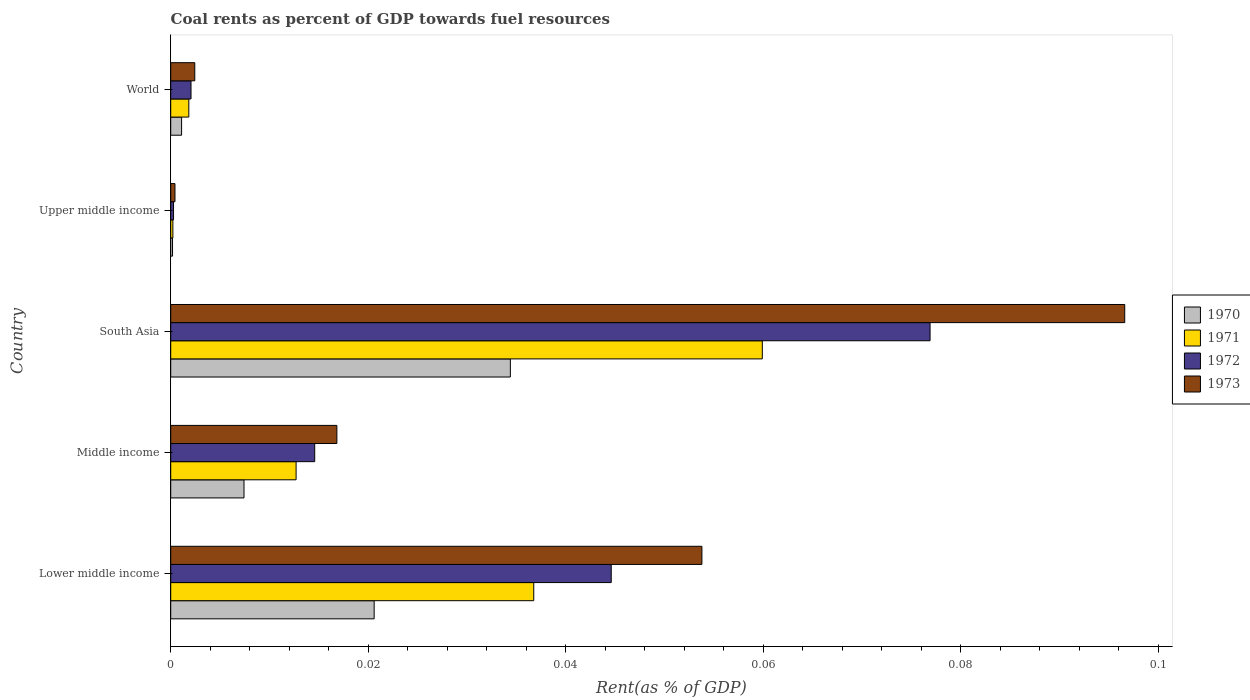How many different coloured bars are there?
Provide a succinct answer. 4. How many groups of bars are there?
Make the answer very short. 5. How many bars are there on the 4th tick from the top?
Provide a succinct answer. 4. What is the label of the 3rd group of bars from the top?
Provide a succinct answer. South Asia. What is the coal rent in 1971 in Lower middle income?
Your response must be concise. 0.04. Across all countries, what is the maximum coal rent in 1972?
Keep it short and to the point. 0.08. Across all countries, what is the minimum coal rent in 1972?
Make the answer very short. 0. In which country was the coal rent in 1970 maximum?
Give a very brief answer. South Asia. In which country was the coal rent in 1971 minimum?
Make the answer very short. Upper middle income. What is the total coal rent in 1970 in the graph?
Offer a very short reply. 0.06. What is the difference between the coal rent in 1972 in Middle income and that in Upper middle income?
Your answer should be very brief. 0.01. What is the difference between the coal rent in 1973 in South Asia and the coal rent in 1970 in Middle income?
Keep it short and to the point. 0.09. What is the average coal rent in 1972 per country?
Ensure brevity in your answer.  0.03. What is the difference between the coal rent in 1973 and coal rent in 1970 in Lower middle income?
Your answer should be very brief. 0.03. What is the ratio of the coal rent in 1970 in Lower middle income to that in Upper middle income?
Ensure brevity in your answer.  112.03. Is the coal rent in 1972 in South Asia less than that in World?
Keep it short and to the point. No. Is the difference between the coal rent in 1973 in Middle income and South Asia greater than the difference between the coal rent in 1970 in Middle income and South Asia?
Your answer should be compact. No. What is the difference between the highest and the second highest coal rent in 1971?
Provide a short and direct response. 0.02. What is the difference between the highest and the lowest coal rent in 1970?
Ensure brevity in your answer.  0.03. How many bars are there?
Give a very brief answer. 20. How many countries are there in the graph?
Your answer should be compact. 5. Does the graph contain grids?
Your answer should be compact. No. How many legend labels are there?
Your answer should be compact. 4. What is the title of the graph?
Give a very brief answer. Coal rents as percent of GDP towards fuel resources. Does "1972" appear as one of the legend labels in the graph?
Ensure brevity in your answer.  Yes. What is the label or title of the X-axis?
Give a very brief answer. Rent(as % of GDP). What is the label or title of the Y-axis?
Make the answer very short. Country. What is the Rent(as % of GDP) in 1970 in Lower middle income?
Your response must be concise. 0.02. What is the Rent(as % of GDP) in 1971 in Lower middle income?
Ensure brevity in your answer.  0.04. What is the Rent(as % of GDP) in 1972 in Lower middle income?
Give a very brief answer. 0.04. What is the Rent(as % of GDP) of 1973 in Lower middle income?
Your response must be concise. 0.05. What is the Rent(as % of GDP) of 1970 in Middle income?
Keep it short and to the point. 0.01. What is the Rent(as % of GDP) of 1971 in Middle income?
Offer a very short reply. 0.01. What is the Rent(as % of GDP) of 1972 in Middle income?
Ensure brevity in your answer.  0.01. What is the Rent(as % of GDP) in 1973 in Middle income?
Offer a terse response. 0.02. What is the Rent(as % of GDP) of 1970 in South Asia?
Provide a succinct answer. 0.03. What is the Rent(as % of GDP) in 1971 in South Asia?
Provide a succinct answer. 0.06. What is the Rent(as % of GDP) of 1972 in South Asia?
Provide a succinct answer. 0.08. What is the Rent(as % of GDP) in 1973 in South Asia?
Your answer should be compact. 0.1. What is the Rent(as % of GDP) of 1970 in Upper middle income?
Keep it short and to the point. 0. What is the Rent(as % of GDP) of 1971 in Upper middle income?
Your answer should be compact. 0. What is the Rent(as % of GDP) in 1972 in Upper middle income?
Offer a terse response. 0. What is the Rent(as % of GDP) of 1973 in Upper middle income?
Your answer should be very brief. 0. What is the Rent(as % of GDP) in 1970 in World?
Your answer should be very brief. 0. What is the Rent(as % of GDP) in 1971 in World?
Offer a very short reply. 0. What is the Rent(as % of GDP) in 1972 in World?
Offer a very short reply. 0. What is the Rent(as % of GDP) of 1973 in World?
Provide a succinct answer. 0. Across all countries, what is the maximum Rent(as % of GDP) of 1970?
Give a very brief answer. 0.03. Across all countries, what is the maximum Rent(as % of GDP) in 1971?
Your response must be concise. 0.06. Across all countries, what is the maximum Rent(as % of GDP) of 1972?
Your response must be concise. 0.08. Across all countries, what is the maximum Rent(as % of GDP) in 1973?
Your response must be concise. 0.1. Across all countries, what is the minimum Rent(as % of GDP) in 1970?
Give a very brief answer. 0. Across all countries, what is the minimum Rent(as % of GDP) in 1971?
Provide a succinct answer. 0. Across all countries, what is the minimum Rent(as % of GDP) in 1972?
Provide a succinct answer. 0. Across all countries, what is the minimum Rent(as % of GDP) in 1973?
Offer a very short reply. 0. What is the total Rent(as % of GDP) in 1970 in the graph?
Your response must be concise. 0.06. What is the total Rent(as % of GDP) in 1971 in the graph?
Your response must be concise. 0.11. What is the total Rent(as % of GDP) in 1972 in the graph?
Make the answer very short. 0.14. What is the total Rent(as % of GDP) of 1973 in the graph?
Your response must be concise. 0.17. What is the difference between the Rent(as % of GDP) in 1970 in Lower middle income and that in Middle income?
Make the answer very short. 0.01. What is the difference between the Rent(as % of GDP) in 1971 in Lower middle income and that in Middle income?
Give a very brief answer. 0.02. What is the difference between the Rent(as % of GDP) in 1972 in Lower middle income and that in Middle income?
Your answer should be compact. 0.03. What is the difference between the Rent(as % of GDP) in 1973 in Lower middle income and that in Middle income?
Your response must be concise. 0.04. What is the difference between the Rent(as % of GDP) in 1970 in Lower middle income and that in South Asia?
Provide a short and direct response. -0.01. What is the difference between the Rent(as % of GDP) of 1971 in Lower middle income and that in South Asia?
Offer a terse response. -0.02. What is the difference between the Rent(as % of GDP) in 1972 in Lower middle income and that in South Asia?
Offer a very short reply. -0.03. What is the difference between the Rent(as % of GDP) of 1973 in Lower middle income and that in South Asia?
Provide a short and direct response. -0.04. What is the difference between the Rent(as % of GDP) in 1970 in Lower middle income and that in Upper middle income?
Offer a very short reply. 0.02. What is the difference between the Rent(as % of GDP) in 1971 in Lower middle income and that in Upper middle income?
Your response must be concise. 0.04. What is the difference between the Rent(as % of GDP) in 1972 in Lower middle income and that in Upper middle income?
Your answer should be very brief. 0.04. What is the difference between the Rent(as % of GDP) in 1973 in Lower middle income and that in Upper middle income?
Provide a succinct answer. 0.05. What is the difference between the Rent(as % of GDP) of 1970 in Lower middle income and that in World?
Make the answer very short. 0.02. What is the difference between the Rent(as % of GDP) in 1971 in Lower middle income and that in World?
Your answer should be very brief. 0.03. What is the difference between the Rent(as % of GDP) in 1972 in Lower middle income and that in World?
Offer a very short reply. 0.04. What is the difference between the Rent(as % of GDP) in 1973 in Lower middle income and that in World?
Your response must be concise. 0.05. What is the difference between the Rent(as % of GDP) of 1970 in Middle income and that in South Asia?
Provide a succinct answer. -0.03. What is the difference between the Rent(as % of GDP) of 1971 in Middle income and that in South Asia?
Provide a succinct answer. -0.05. What is the difference between the Rent(as % of GDP) of 1972 in Middle income and that in South Asia?
Ensure brevity in your answer.  -0.06. What is the difference between the Rent(as % of GDP) in 1973 in Middle income and that in South Asia?
Provide a succinct answer. -0.08. What is the difference between the Rent(as % of GDP) in 1970 in Middle income and that in Upper middle income?
Ensure brevity in your answer.  0.01. What is the difference between the Rent(as % of GDP) of 1971 in Middle income and that in Upper middle income?
Give a very brief answer. 0.01. What is the difference between the Rent(as % of GDP) in 1972 in Middle income and that in Upper middle income?
Offer a terse response. 0.01. What is the difference between the Rent(as % of GDP) of 1973 in Middle income and that in Upper middle income?
Give a very brief answer. 0.02. What is the difference between the Rent(as % of GDP) in 1970 in Middle income and that in World?
Offer a terse response. 0.01. What is the difference between the Rent(as % of GDP) of 1971 in Middle income and that in World?
Offer a terse response. 0.01. What is the difference between the Rent(as % of GDP) of 1972 in Middle income and that in World?
Ensure brevity in your answer.  0.01. What is the difference between the Rent(as % of GDP) in 1973 in Middle income and that in World?
Your answer should be very brief. 0.01. What is the difference between the Rent(as % of GDP) of 1970 in South Asia and that in Upper middle income?
Provide a succinct answer. 0.03. What is the difference between the Rent(as % of GDP) of 1971 in South Asia and that in Upper middle income?
Give a very brief answer. 0.06. What is the difference between the Rent(as % of GDP) of 1972 in South Asia and that in Upper middle income?
Your response must be concise. 0.08. What is the difference between the Rent(as % of GDP) in 1973 in South Asia and that in Upper middle income?
Ensure brevity in your answer.  0.1. What is the difference between the Rent(as % of GDP) of 1970 in South Asia and that in World?
Your answer should be compact. 0.03. What is the difference between the Rent(as % of GDP) in 1971 in South Asia and that in World?
Your response must be concise. 0.06. What is the difference between the Rent(as % of GDP) in 1972 in South Asia and that in World?
Ensure brevity in your answer.  0.07. What is the difference between the Rent(as % of GDP) in 1973 in South Asia and that in World?
Your response must be concise. 0.09. What is the difference between the Rent(as % of GDP) of 1970 in Upper middle income and that in World?
Offer a terse response. -0. What is the difference between the Rent(as % of GDP) of 1971 in Upper middle income and that in World?
Your answer should be compact. -0. What is the difference between the Rent(as % of GDP) of 1972 in Upper middle income and that in World?
Offer a terse response. -0. What is the difference between the Rent(as % of GDP) of 1973 in Upper middle income and that in World?
Your answer should be compact. -0. What is the difference between the Rent(as % of GDP) in 1970 in Lower middle income and the Rent(as % of GDP) in 1971 in Middle income?
Provide a short and direct response. 0.01. What is the difference between the Rent(as % of GDP) in 1970 in Lower middle income and the Rent(as % of GDP) in 1972 in Middle income?
Offer a terse response. 0.01. What is the difference between the Rent(as % of GDP) of 1970 in Lower middle income and the Rent(as % of GDP) of 1973 in Middle income?
Your answer should be compact. 0. What is the difference between the Rent(as % of GDP) in 1971 in Lower middle income and the Rent(as % of GDP) in 1972 in Middle income?
Your response must be concise. 0.02. What is the difference between the Rent(as % of GDP) in 1971 in Lower middle income and the Rent(as % of GDP) in 1973 in Middle income?
Provide a short and direct response. 0.02. What is the difference between the Rent(as % of GDP) of 1972 in Lower middle income and the Rent(as % of GDP) of 1973 in Middle income?
Your response must be concise. 0.03. What is the difference between the Rent(as % of GDP) in 1970 in Lower middle income and the Rent(as % of GDP) in 1971 in South Asia?
Provide a succinct answer. -0.04. What is the difference between the Rent(as % of GDP) of 1970 in Lower middle income and the Rent(as % of GDP) of 1972 in South Asia?
Give a very brief answer. -0.06. What is the difference between the Rent(as % of GDP) of 1970 in Lower middle income and the Rent(as % of GDP) of 1973 in South Asia?
Provide a succinct answer. -0.08. What is the difference between the Rent(as % of GDP) in 1971 in Lower middle income and the Rent(as % of GDP) in 1972 in South Asia?
Provide a short and direct response. -0.04. What is the difference between the Rent(as % of GDP) of 1971 in Lower middle income and the Rent(as % of GDP) of 1973 in South Asia?
Provide a short and direct response. -0.06. What is the difference between the Rent(as % of GDP) in 1972 in Lower middle income and the Rent(as % of GDP) in 1973 in South Asia?
Your answer should be compact. -0.05. What is the difference between the Rent(as % of GDP) of 1970 in Lower middle income and the Rent(as % of GDP) of 1971 in Upper middle income?
Keep it short and to the point. 0.02. What is the difference between the Rent(as % of GDP) in 1970 in Lower middle income and the Rent(as % of GDP) in 1972 in Upper middle income?
Make the answer very short. 0.02. What is the difference between the Rent(as % of GDP) in 1970 in Lower middle income and the Rent(as % of GDP) in 1973 in Upper middle income?
Offer a very short reply. 0.02. What is the difference between the Rent(as % of GDP) in 1971 in Lower middle income and the Rent(as % of GDP) in 1972 in Upper middle income?
Provide a short and direct response. 0.04. What is the difference between the Rent(as % of GDP) in 1971 in Lower middle income and the Rent(as % of GDP) in 1973 in Upper middle income?
Provide a succinct answer. 0.04. What is the difference between the Rent(as % of GDP) of 1972 in Lower middle income and the Rent(as % of GDP) of 1973 in Upper middle income?
Ensure brevity in your answer.  0.04. What is the difference between the Rent(as % of GDP) in 1970 in Lower middle income and the Rent(as % of GDP) in 1971 in World?
Provide a succinct answer. 0.02. What is the difference between the Rent(as % of GDP) in 1970 in Lower middle income and the Rent(as % of GDP) in 1972 in World?
Your response must be concise. 0.02. What is the difference between the Rent(as % of GDP) of 1970 in Lower middle income and the Rent(as % of GDP) of 1973 in World?
Your response must be concise. 0.02. What is the difference between the Rent(as % of GDP) of 1971 in Lower middle income and the Rent(as % of GDP) of 1972 in World?
Provide a succinct answer. 0.03. What is the difference between the Rent(as % of GDP) in 1971 in Lower middle income and the Rent(as % of GDP) in 1973 in World?
Offer a terse response. 0.03. What is the difference between the Rent(as % of GDP) in 1972 in Lower middle income and the Rent(as % of GDP) in 1973 in World?
Make the answer very short. 0.04. What is the difference between the Rent(as % of GDP) in 1970 in Middle income and the Rent(as % of GDP) in 1971 in South Asia?
Provide a short and direct response. -0.05. What is the difference between the Rent(as % of GDP) of 1970 in Middle income and the Rent(as % of GDP) of 1972 in South Asia?
Provide a short and direct response. -0.07. What is the difference between the Rent(as % of GDP) of 1970 in Middle income and the Rent(as % of GDP) of 1973 in South Asia?
Give a very brief answer. -0.09. What is the difference between the Rent(as % of GDP) of 1971 in Middle income and the Rent(as % of GDP) of 1972 in South Asia?
Your answer should be very brief. -0.06. What is the difference between the Rent(as % of GDP) in 1971 in Middle income and the Rent(as % of GDP) in 1973 in South Asia?
Offer a terse response. -0.08. What is the difference between the Rent(as % of GDP) in 1972 in Middle income and the Rent(as % of GDP) in 1973 in South Asia?
Provide a succinct answer. -0.08. What is the difference between the Rent(as % of GDP) in 1970 in Middle income and the Rent(as % of GDP) in 1971 in Upper middle income?
Provide a short and direct response. 0.01. What is the difference between the Rent(as % of GDP) of 1970 in Middle income and the Rent(as % of GDP) of 1972 in Upper middle income?
Your answer should be compact. 0.01. What is the difference between the Rent(as % of GDP) of 1970 in Middle income and the Rent(as % of GDP) of 1973 in Upper middle income?
Your answer should be very brief. 0.01. What is the difference between the Rent(as % of GDP) in 1971 in Middle income and the Rent(as % of GDP) in 1972 in Upper middle income?
Ensure brevity in your answer.  0.01. What is the difference between the Rent(as % of GDP) of 1971 in Middle income and the Rent(as % of GDP) of 1973 in Upper middle income?
Provide a short and direct response. 0.01. What is the difference between the Rent(as % of GDP) of 1972 in Middle income and the Rent(as % of GDP) of 1973 in Upper middle income?
Offer a very short reply. 0.01. What is the difference between the Rent(as % of GDP) in 1970 in Middle income and the Rent(as % of GDP) in 1971 in World?
Offer a terse response. 0.01. What is the difference between the Rent(as % of GDP) of 1970 in Middle income and the Rent(as % of GDP) of 1972 in World?
Give a very brief answer. 0.01. What is the difference between the Rent(as % of GDP) in 1970 in Middle income and the Rent(as % of GDP) in 1973 in World?
Your response must be concise. 0.01. What is the difference between the Rent(as % of GDP) in 1971 in Middle income and the Rent(as % of GDP) in 1972 in World?
Offer a very short reply. 0.01. What is the difference between the Rent(as % of GDP) in 1971 in Middle income and the Rent(as % of GDP) in 1973 in World?
Provide a succinct answer. 0.01. What is the difference between the Rent(as % of GDP) of 1972 in Middle income and the Rent(as % of GDP) of 1973 in World?
Ensure brevity in your answer.  0.01. What is the difference between the Rent(as % of GDP) of 1970 in South Asia and the Rent(as % of GDP) of 1971 in Upper middle income?
Your answer should be compact. 0.03. What is the difference between the Rent(as % of GDP) of 1970 in South Asia and the Rent(as % of GDP) of 1972 in Upper middle income?
Your answer should be compact. 0.03. What is the difference between the Rent(as % of GDP) in 1970 in South Asia and the Rent(as % of GDP) in 1973 in Upper middle income?
Offer a very short reply. 0.03. What is the difference between the Rent(as % of GDP) of 1971 in South Asia and the Rent(as % of GDP) of 1972 in Upper middle income?
Offer a very short reply. 0.06. What is the difference between the Rent(as % of GDP) in 1971 in South Asia and the Rent(as % of GDP) in 1973 in Upper middle income?
Give a very brief answer. 0.06. What is the difference between the Rent(as % of GDP) of 1972 in South Asia and the Rent(as % of GDP) of 1973 in Upper middle income?
Your answer should be very brief. 0.08. What is the difference between the Rent(as % of GDP) in 1970 in South Asia and the Rent(as % of GDP) in 1971 in World?
Your answer should be very brief. 0.03. What is the difference between the Rent(as % of GDP) of 1970 in South Asia and the Rent(as % of GDP) of 1972 in World?
Offer a very short reply. 0.03. What is the difference between the Rent(as % of GDP) of 1970 in South Asia and the Rent(as % of GDP) of 1973 in World?
Make the answer very short. 0.03. What is the difference between the Rent(as % of GDP) of 1971 in South Asia and the Rent(as % of GDP) of 1972 in World?
Offer a terse response. 0.06. What is the difference between the Rent(as % of GDP) of 1971 in South Asia and the Rent(as % of GDP) of 1973 in World?
Offer a very short reply. 0.06. What is the difference between the Rent(as % of GDP) in 1972 in South Asia and the Rent(as % of GDP) in 1973 in World?
Your response must be concise. 0.07. What is the difference between the Rent(as % of GDP) in 1970 in Upper middle income and the Rent(as % of GDP) in 1971 in World?
Offer a terse response. -0. What is the difference between the Rent(as % of GDP) of 1970 in Upper middle income and the Rent(as % of GDP) of 1972 in World?
Make the answer very short. -0. What is the difference between the Rent(as % of GDP) in 1970 in Upper middle income and the Rent(as % of GDP) in 1973 in World?
Make the answer very short. -0. What is the difference between the Rent(as % of GDP) in 1971 in Upper middle income and the Rent(as % of GDP) in 1972 in World?
Your response must be concise. -0. What is the difference between the Rent(as % of GDP) of 1971 in Upper middle income and the Rent(as % of GDP) of 1973 in World?
Your response must be concise. -0. What is the difference between the Rent(as % of GDP) in 1972 in Upper middle income and the Rent(as % of GDP) in 1973 in World?
Your answer should be compact. -0. What is the average Rent(as % of GDP) in 1970 per country?
Provide a succinct answer. 0.01. What is the average Rent(as % of GDP) in 1971 per country?
Make the answer very short. 0.02. What is the average Rent(as % of GDP) in 1972 per country?
Keep it short and to the point. 0.03. What is the average Rent(as % of GDP) of 1973 per country?
Provide a short and direct response. 0.03. What is the difference between the Rent(as % of GDP) of 1970 and Rent(as % of GDP) of 1971 in Lower middle income?
Your answer should be compact. -0.02. What is the difference between the Rent(as % of GDP) in 1970 and Rent(as % of GDP) in 1972 in Lower middle income?
Keep it short and to the point. -0.02. What is the difference between the Rent(as % of GDP) of 1970 and Rent(as % of GDP) of 1973 in Lower middle income?
Provide a short and direct response. -0.03. What is the difference between the Rent(as % of GDP) of 1971 and Rent(as % of GDP) of 1972 in Lower middle income?
Your answer should be compact. -0.01. What is the difference between the Rent(as % of GDP) of 1971 and Rent(as % of GDP) of 1973 in Lower middle income?
Ensure brevity in your answer.  -0.02. What is the difference between the Rent(as % of GDP) of 1972 and Rent(as % of GDP) of 1973 in Lower middle income?
Your answer should be very brief. -0.01. What is the difference between the Rent(as % of GDP) of 1970 and Rent(as % of GDP) of 1971 in Middle income?
Keep it short and to the point. -0.01. What is the difference between the Rent(as % of GDP) of 1970 and Rent(as % of GDP) of 1972 in Middle income?
Your answer should be very brief. -0.01. What is the difference between the Rent(as % of GDP) of 1970 and Rent(as % of GDP) of 1973 in Middle income?
Make the answer very short. -0.01. What is the difference between the Rent(as % of GDP) in 1971 and Rent(as % of GDP) in 1972 in Middle income?
Give a very brief answer. -0. What is the difference between the Rent(as % of GDP) in 1971 and Rent(as % of GDP) in 1973 in Middle income?
Keep it short and to the point. -0. What is the difference between the Rent(as % of GDP) of 1972 and Rent(as % of GDP) of 1973 in Middle income?
Your answer should be compact. -0. What is the difference between the Rent(as % of GDP) in 1970 and Rent(as % of GDP) in 1971 in South Asia?
Ensure brevity in your answer.  -0.03. What is the difference between the Rent(as % of GDP) of 1970 and Rent(as % of GDP) of 1972 in South Asia?
Make the answer very short. -0.04. What is the difference between the Rent(as % of GDP) in 1970 and Rent(as % of GDP) in 1973 in South Asia?
Make the answer very short. -0.06. What is the difference between the Rent(as % of GDP) in 1971 and Rent(as % of GDP) in 1972 in South Asia?
Ensure brevity in your answer.  -0.02. What is the difference between the Rent(as % of GDP) of 1971 and Rent(as % of GDP) of 1973 in South Asia?
Your answer should be very brief. -0.04. What is the difference between the Rent(as % of GDP) in 1972 and Rent(as % of GDP) in 1973 in South Asia?
Provide a short and direct response. -0.02. What is the difference between the Rent(as % of GDP) of 1970 and Rent(as % of GDP) of 1972 in Upper middle income?
Offer a very short reply. -0. What is the difference between the Rent(as % of GDP) of 1970 and Rent(as % of GDP) of 1973 in Upper middle income?
Ensure brevity in your answer.  -0. What is the difference between the Rent(as % of GDP) of 1971 and Rent(as % of GDP) of 1972 in Upper middle income?
Your answer should be very brief. -0. What is the difference between the Rent(as % of GDP) in 1971 and Rent(as % of GDP) in 1973 in Upper middle income?
Give a very brief answer. -0. What is the difference between the Rent(as % of GDP) in 1972 and Rent(as % of GDP) in 1973 in Upper middle income?
Provide a succinct answer. -0. What is the difference between the Rent(as % of GDP) of 1970 and Rent(as % of GDP) of 1971 in World?
Offer a terse response. -0. What is the difference between the Rent(as % of GDP) in 1970 and Rent(as % of GDP) in 1972 in World?
Give a very brief answer. -0. What is the difference between the Rent(as % of GDP) of 1970 and Rent(as % of GDP) of 1973 in World?
Your answer should be compact. -0. What is the difference between the Rent(as % of GDP) of 1971 and Rent(as % of GDP) of 1972 in World?
Offer a very short reply. -0. What is the difference between the Rent(as % of GDP) of 1971 and Rent(as % of GDP) of 1973 in World?
Make the answer very short. -0. What is the difference between the Rent(as % of GDP) of 1972 and Rent(as % of GDP) of 1973 in World?
Give a very brief answer. -0. What is the ratio of the Rent(as % of GDP) in 1970 in Lower middle income to that in Middle income?
Your response must be concise. 2.78. What is the ratio of the Rent(as % of GDP) of 1971 in Lower middle income to that in Middle income?
Your response must be concise. 2.9. What is the ratio of the Rent(as % of GDP) of 1972 in Lower middle income to that in Middle income?
Ensure brevity in your answer.  3.06. What is the ratio of the Rent(as % of GDP) in 1973 in Lower middle income to that in Middle income?
Make the answer very short. 3.2. What is the ratio of the Rent(as % of GDP) of 1970 in Lower middle income to that in South Asia?
Offer a terse response. 0.6. What is the ratio of the Rent(as % of GDP) in 1971 in Lower middle income to that in South Asia?
Give a very brief answer. 0.61. What is the ratio of the Rent(as % of GDP) in 1972 in Lower middle income to that in South Asia?
Make the answer very short. 0.58. What is the ratio of the Rent(as % of GDP) of 1973 in Lower middle income to that in South Asia?
Keep it short and to the point. 0.56. What is the ratio of the Rent(as % of GDP) of 1970 in Lower middle income to that in Upper middle income?
Give a very brief answer. 112.03. What is the ratio of the Rent(as % of GDP) of 1971 in Lower middle income to that in Upper middle income?
Your response must be concise. 167.98. What is the ratio of the Rent(as % of GDP) of 1972 in Lower middle income to that in Upper middle income?
Your answer should be very brief. 156.82. What is the ratio of the Rent(as % of GDP) of 1973 in Lower middle income to that in Upper middle income?
Provide a succinct answer. 124.82. What is the ratio of the Rent(as % of GDP) of 1970 in Lower middle income to that in World?
Your answer should be very brief. 18.71. What is the ratio of the Rent(as % of GDP) in 1971 in Lower middle income to that in World?
Your answer should be very brief. 20.06. What is the ratio of the Rent(as % of GDP) of 1972 in Lower middle income to that in World?
Make the answer very short. 21.7. What is the ratio of the Rent(as % of GDP) of 1973 in Lower middle income to that in World?
Your answer should be very brief. 22.07. What is the ratio of the Rent(as % of GDP) in 1970 in Middle income to that in South Asia?
Keep it short and to the point. 0.22. What is the ratio of the Rent(as % of GDP) in 1971 in Middle income to that in South Asia?
Your answer should be compact. 0.21. What is the ratio of the Rent(as % of GDP) in 1972 in Middle income to that in South Asia?
Your response must be concise. 0.19. What is the ratio of the Rent(as % of GDP) in 1973 in Middle income to that in South Asia?
Provide a short and direct response. 0.17. What is the ratio of the Rent(as % of GDP) of 1970 in Middle income to that in Upper middle income?
Make the answer very short. 40.36. What is the ratio of the Rent(as % of GDP) in 1971 in Middle income to that in Upper middle income?
Your answer should be compact. 58.01. What is the ratio of the Rent(as % of GDP) of 1972 in Middle income to that in Upper middle income?
Offer a very short reply. 51.25. What is the ratio of the Rent(as % of GDP) in 1973 in Middle income to that in Upper middle income?
Make the answer very short. 39.04. What is the ratio of the Rent(as % of GDP) of 1970 in Middle income to that in World?
Provide a succinct answer. 6.74. What is the ratio of the Rent(as % of GDP) of 1971 in Middle income to that in World?
Offer a terse response. 6.93. What is the ratio of the Rent(as % of GDP) of 1972 in Middle income to that in World?
Your response must be concise. 7.09. What is the ratio of the Rent(as % of GDP) in 1973 in Middle income to that in World?
Give a very brief answer. 6.91. What is the ratio of the Rent(as % of GDP) in 1970 in South Asia to that in Upper middle income?
Offer a very short reply. 187.05. What is the ratio of the Rent(as % of GDP) in 1971 in South Asia to that in Upper middle income?
Make the answer very short. 273.74. What is the ratio of the Rent(as % of GDP) of 1972 in South Asia to that in Upper middle income?
Offer a terse response. 270.32. What is the ratio of the Rent(as % of GDP) in 1973 in South Asia to that in Upper middle income?
Your response must be concise. 224.18. What is the ratio of the Rent(as % of GDP) of 1970 in South Asia to that in World?
Offer a very short reply. 31.24. What is the ratio of the Rent(as % of GDP) in 1971 in South Asia to that in World?
Your answer should be very brief. 32.69. What is the ratio of the Rent(as % of GDP) of 1972 in South Asia to that in World?
Provide a succinct answer. 37.41. What is the ratio of the Rent(as % of GDP) of 1973 in South Asia to that in World?
Your response must be concise. 39.65. What is the ratio of the Rent(as % of GDP) in 1970 in Upper middle income to that in World?
Provide a succinct answer. 0.17. What is the ratio of the Rent(as % of GDP) of 1971 in Upper middle income to that in World?
Offer a very short reply. 0.12. What is the ratio of the Rent(as % of GDP) of 1972 in Upper middle income to that in World?
Offer a terse response. 0.14. What is the ratio of the Rent(as % of GDP) of 1973 in Upper middle income to that in World?
Give a very brief answer. 0.18. What is the difference between the highest and the second highest Rent(as % of GDP) in 1970?
Your answer should be compact. 0.01. What is the difference between the highest and the second highest Rent(as % of GDP) in 1971?
Provide a short and direct response. 0.02. What is the difference between the highest and the second highest Rent(as % of GDP) in 1972?
Give a very brief answer. 0.03. What is the difference between the highest and the second highest Rent(as % of GDP) in 1973?
Offer a very short reply. 0.04. What is the difference between the highest and the lowest Rent(as % of GDP) of 1970?
Provide a short and direct response. 0.03. What is the difference between the highest and the lowest Rent(as % of GDP) of 1971?
Offer a very short reply. 0.06. What is the difference between the highest and the lowest Rent(as % of GDP) in 1972?
Your answer should be compact. 0.08. What is the difference between the highest and the lowest Rent(as % of GDP) in 1973?
Provide a succinct answer. 0.1. 